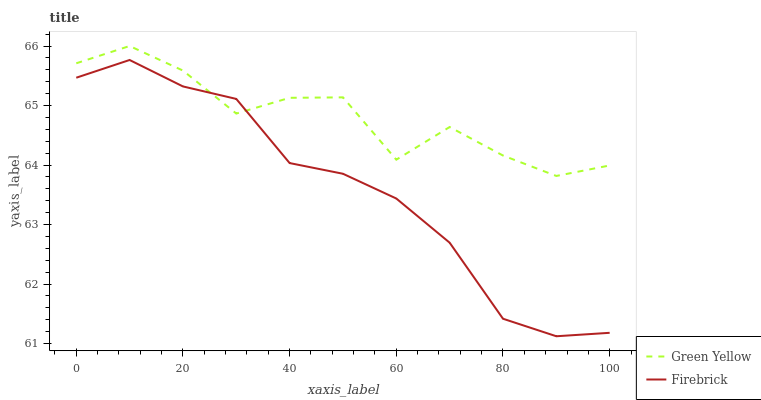Does Firebrick have the minimum area under the curve?
Answer yes or no. Yes. Does Green Yellow have the maximum area under the curve?
Answer yes or no. Yes. Does Green Yellow have the minimum area under the curve?
Answer yes or no. No. Is Firebrick the smoothest?
Answer yes or no. Yes. Is Green Yellow the roughest?
Answer yes or no. Yes. Is Green Yellow the smoothest?
Answer yes or no. No. Does Firebrick have the lowest value?
Answer yes or no. Yes. Does Green Yellow have the lowest value?
Answer yes or no. No. Does Green Yellow have the highest value?
Answer yes or no. Yes. Does Green Yellow intersect Firebrick?
Answer yes or no. Yes. Is Green Yellow less than Firebrick?
Answer yes or no. No. Is Green Yellow greater than Firebrick?
Answer yes or no. No. 